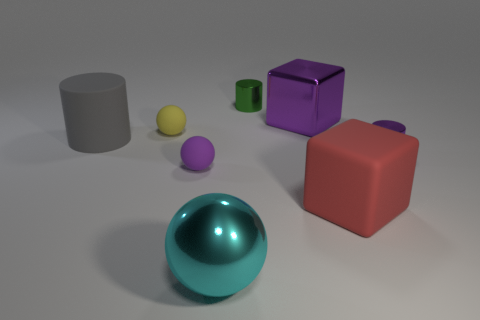There is a cylinder that is to the left of the cyan metallic ball; how big is it?
Make the answer very short. Large. What number of other objects are the same color as the large matte cylinder?
Give a very brief answer. 0. What material is the block that is in front of the small rubber ball that is behind the purple rubber thing?
Make the answer very short. Rubber. Is the color of the large shiny object on the left side of the small green shiny cylinder the same as the big metallic block?
Your answer should be compact. No. Is there anything else that has the same material as the large cyan sphere?
Make the answer very short. Yes. How many other rubber objects are the same shape as the yellow thing?
Your answer should be very brief. 1. The yellow sphere that is made of the same material as the large cylinder is what size?
Make the answer very short. Small. Is there a cyan ball that is right of the small metal object in front of the metallic cylinder on the left side of the red matte block?
Your answer should be compact. No. There is a cyan metal ball that is to the left of the purple metal cylinder; does it have the same size as the big rubber cylinder?
Ensure brevity in your answer.  Yes. How many red cylinders have the same size as the cyan metallic object?
Your answer should be very brief. 0. 